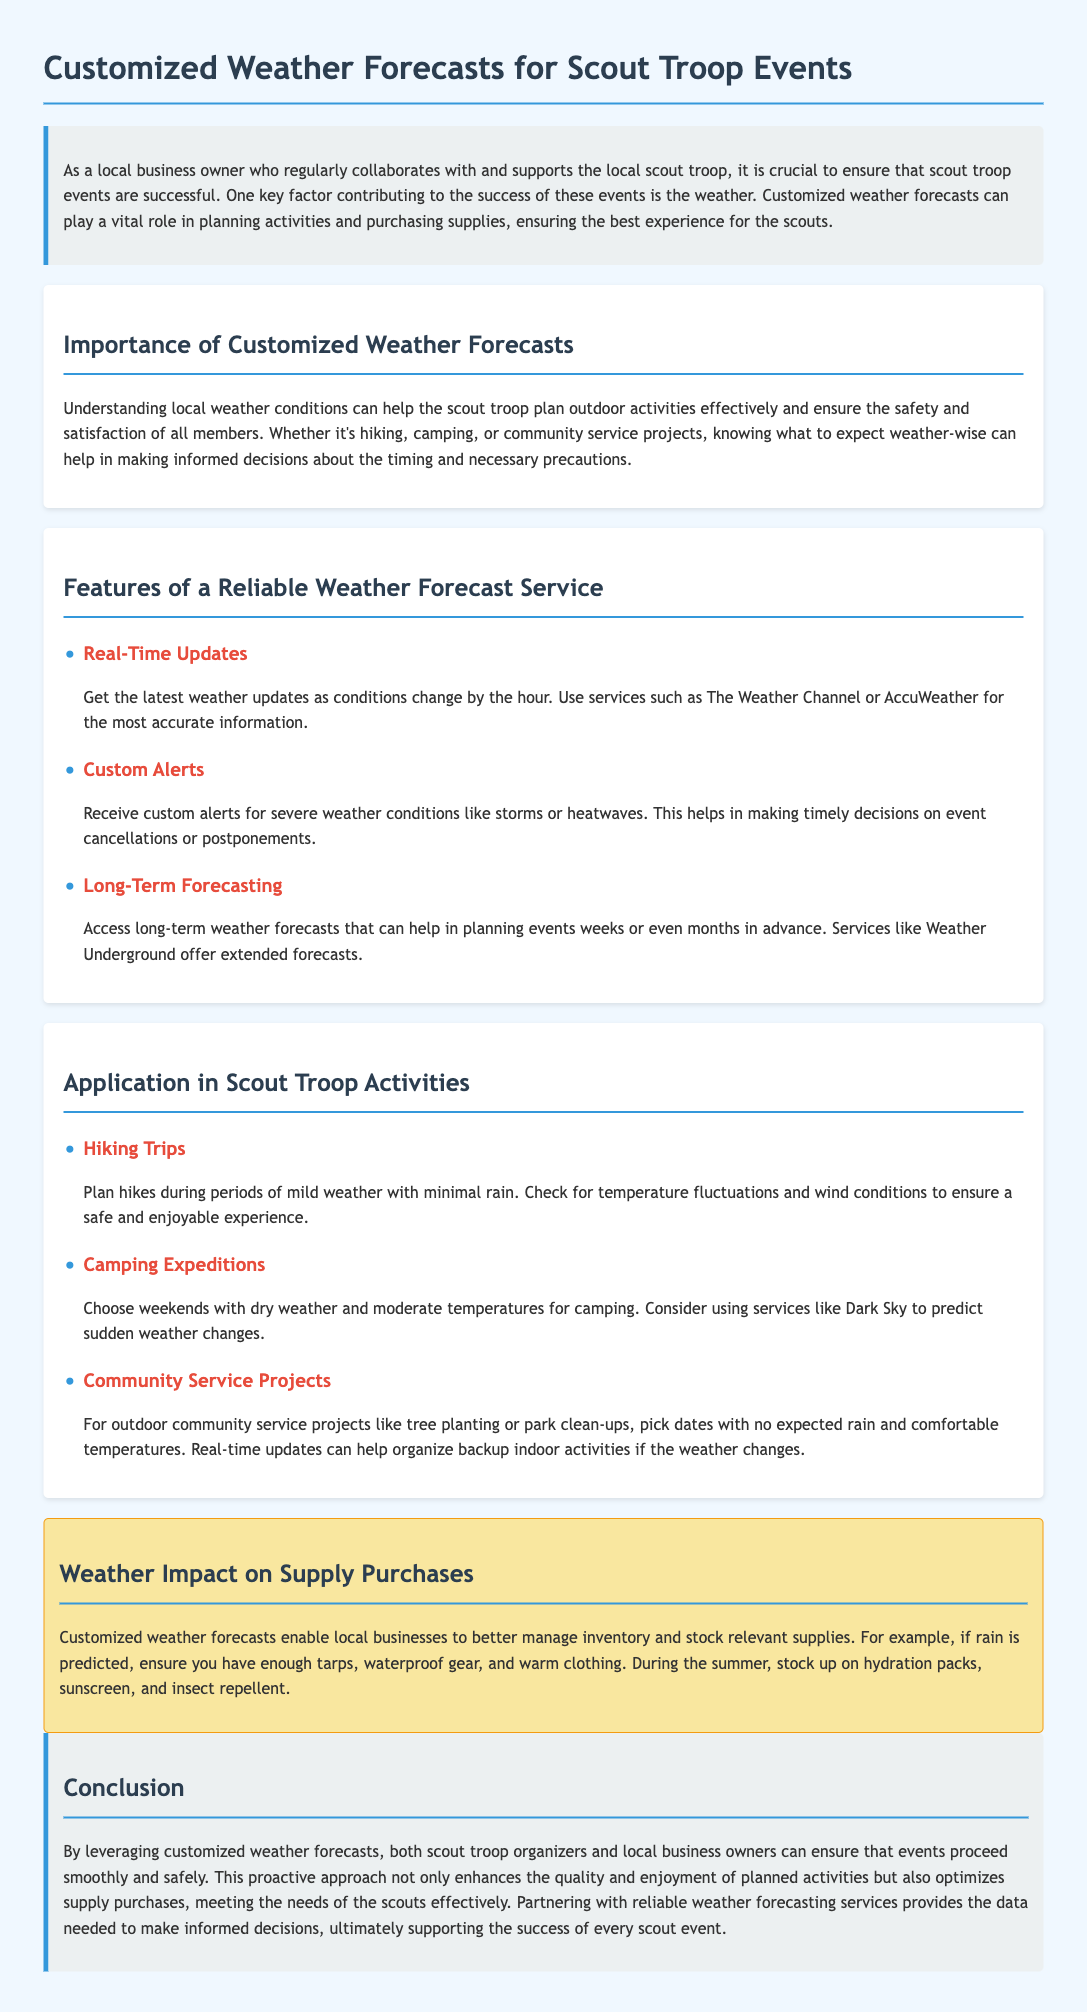What is the title of the document? The title of the document can be found at the top of the page, and it summarizes the main purpose of the content.
Answer: Customized Weather Forecasts for Scout Troop Events What is one feature of a reliable weather forecast service? The document lists multiple features, with each having a dedicated section.
Answer: Real-Time Updates What is a weather impact mentioned in the document? The document discusses how weather conditions affect various aspects of scout troop activities and supply purchases.
Answer: Inventory management What is the suggested weather condition for hiking trips? The document specifically states the recommended weather conditions for planned activities like hiking trips.
Answer: Mild weather with minimal rain Which service is recommended for long-term forecasting? The document mentions a specific service for long-term weather forecasts.
Answer: Weather Underground What is the main purpose of customized weather forecasts? The introduction of the document outlines the primary objective of utilizing customized forecasts.
Answer: Ensure successful scout events What type of activity is recommended to be planned during dry weather? The section discussing different activities indicates when to plan specific events based on weather conditions.
Answer: Camping Expeditions What should be stocked up during summer according to the document? The document provides examples of supplies to manage based on predicted weather conditions during different seasons.
Answer: Hydration packs How does the document suggest ensuring timely decisions? The document elaborates on how real-time weather updates can aid in making decisions regarding events.
Answer: Custom alerts 